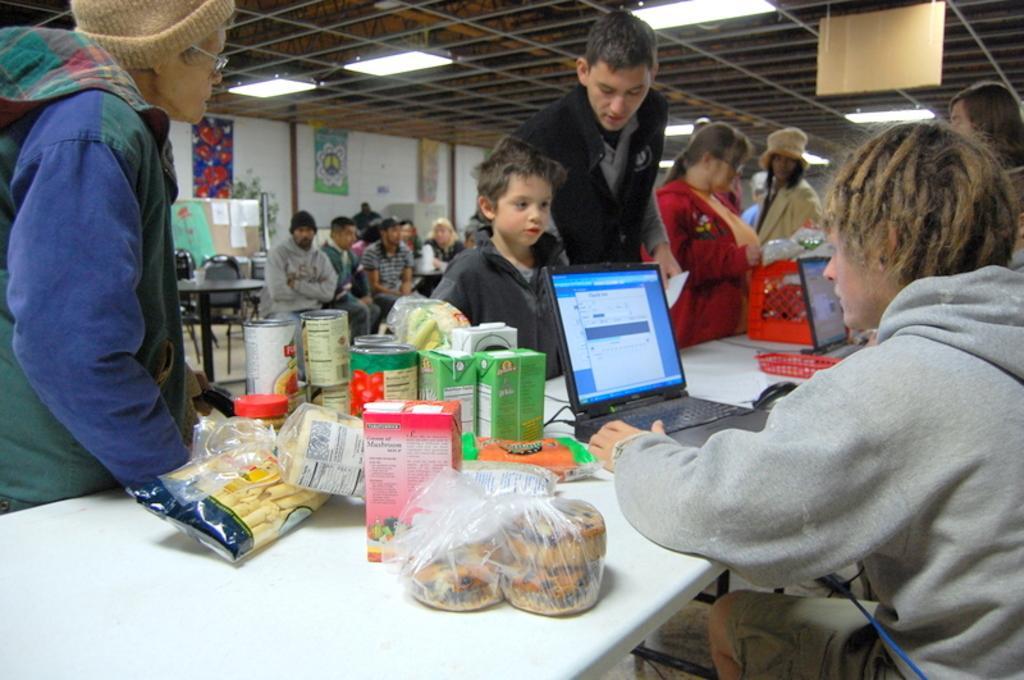Could you give a brief overview of what you see in this image? In this image we can see some people and among them few people are standing and few people are sitting on chairs and there is a table with two laptops and some other things and we can see some posters attached to the wall in the background. At the top we can see some lights attached to the ceiling. 